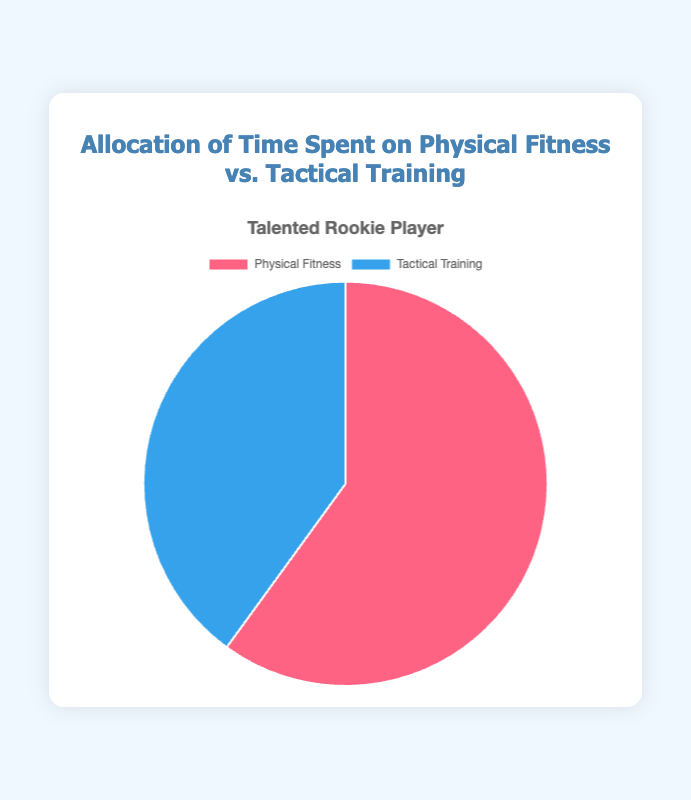What portion of time does the Talented Rookie Player spend on physical fitness? The figure shows that the Talented Rookie Player spends 60% of their time on physical fitness, and 40% on tactical training.
Answer: 60% Compare the time spent on tactical training by the Talented Rookie Player and the Team Captain. The Talented Rookie Player spends 40% of their time on tactical training, while the Team Captain spends 50% of their time on tactical training. Thus, the Team Captain spends more time on tactical training.
Answer: Team Captain How much more time does the Talented Rookie Player spend on physical fitness compared to tactical training? The Talented Rookie Player spends 60% on physical fitness and 40% on tactical training. The difference is 60% - 40%.
Answer: 20% If the Talented Rookie Player decides to allocate an equal amount of time to both physical fitness and tactical training, by how much should they decrease the time spent on physical fitness? Currently, the Talented Rookie Player spends 60% on physical fitness. To make it equal to tactical training at 40%, they need to decrease the time spent on physical fitness by 20%.
Answer: 20% What is the combined percentage of time spent on tactical training by the Talented Rookie Player and the Team Captain? The Talented Rookie Player spends 40% and the Team Captain spends 50% on tactical training. Adding these together results in 40% + 50%.
Answer: 90% Compare visually, which has a larger segment in the pie chart for Talented Rookie Player – physical fitness or tactical training? The pie chart for Talented Rookie Player shows that the segment for physical fitness is larger than for tactical training, with physical fitness at 60% and tactical training at 40%.
Answer: Physical fitness 